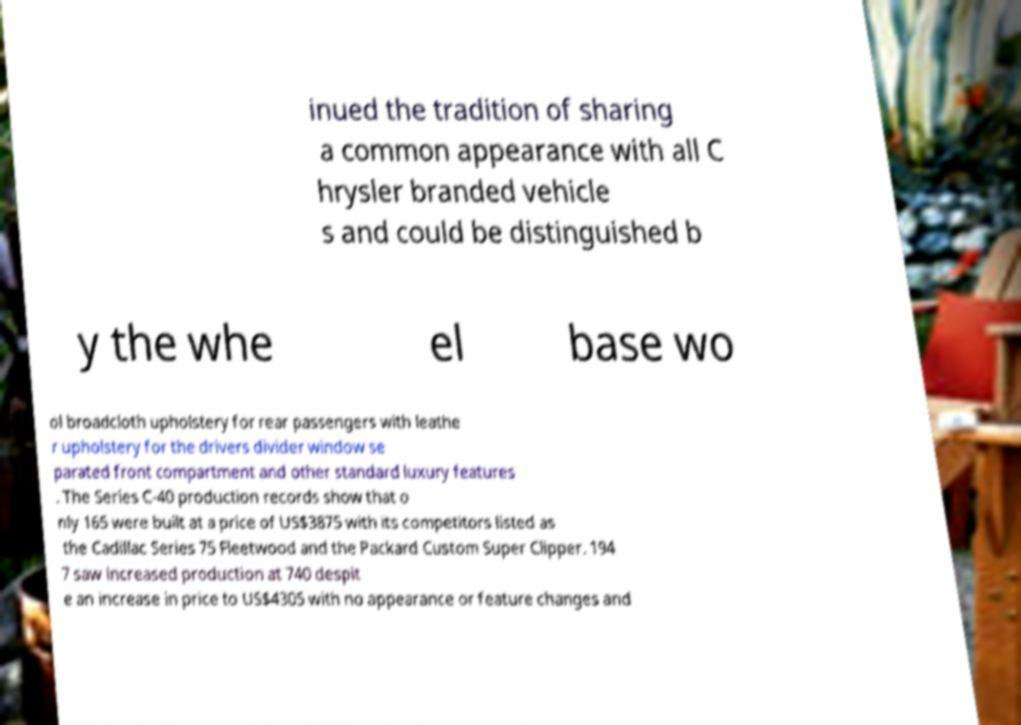There's text embedded in this image that I need extracted. Can you transcribe it verbatim? inued the tradition of sharing a common appearance with all C hrysler branded vehicle s and could be distinguished b y the whe el base wo ol broadcloth upholstery for rear passengers with leathe r upholstery for the drivers divider window se parated front compartment and other standard luxury features . The Series C-40 production records show that o nly 165 were built at a price of US$3875 with its competitors listed as the Cadillac Series 75 Fleetwood and the Packard Custom Super Clipper. 194 7 saw increased production at 740 despit e an increase in price to US$4305 with no appearance or feature changes and 